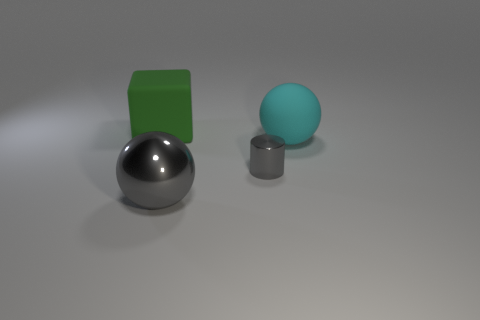Add 1 large blue matte things. How many objects exist? 5 Subtract all cylinders. How many objects are left? 3 Add 3 gray metallic things. How many gray metallic things are left? 5 Add 3 big rubber objects. How many big rubber objects exist? 5 Subtract 0 blue balls. How many objects are left? 4 Subtract all big cyan metallic cylinders. Subtract all large matte things. How many objects are left? 2 